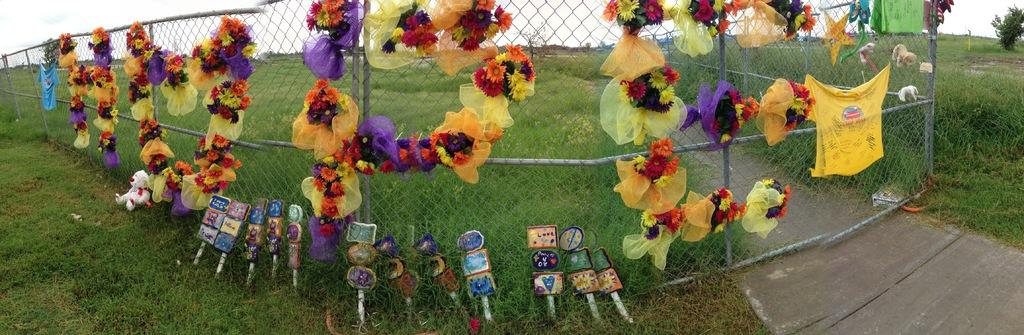What is in the foreground of the image? There is grass, sticks, and garlands on a fence in the foreground of the image. What can be seen in the background of the image? There are toys, trees, houses, and the sky visible in the background of the image. What is the time of day when the image was likely taken? The image was likely taken during the day, as the sky is visible. What type of fruit is hanging from the trees in the background of the image? There is no fruit hanging from the trees in the image; only trees are visible in the background. Can you hear a drum being played in the image? There is no indication of sound in the image, so it cannot be determined if a drum is being played. 